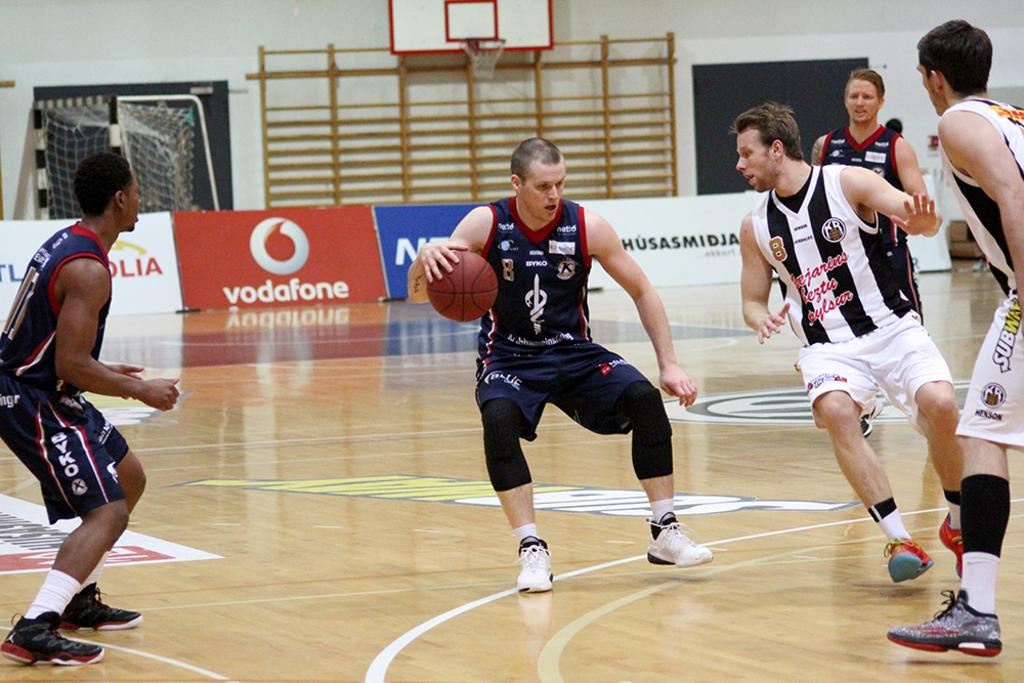<image>
Summarize the visual content of the image. some basketball players with the word vodafone in the background 